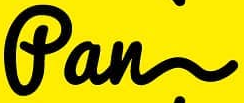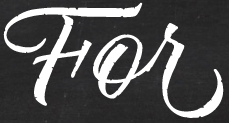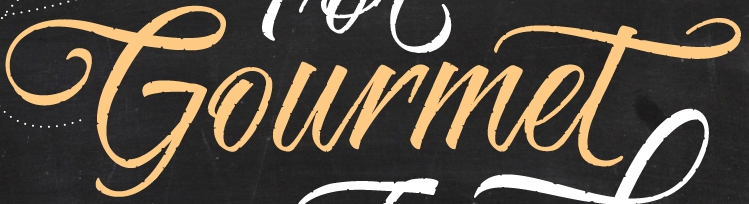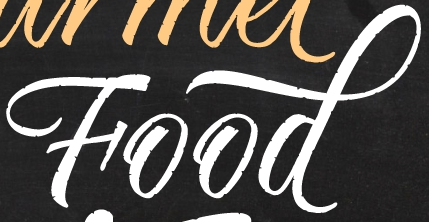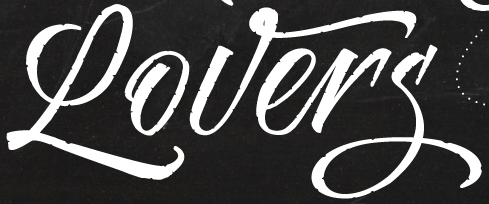What text is displayed in these images sequentially, separated by a semicolon? fan; For; Gourmet; Food; Lovers 